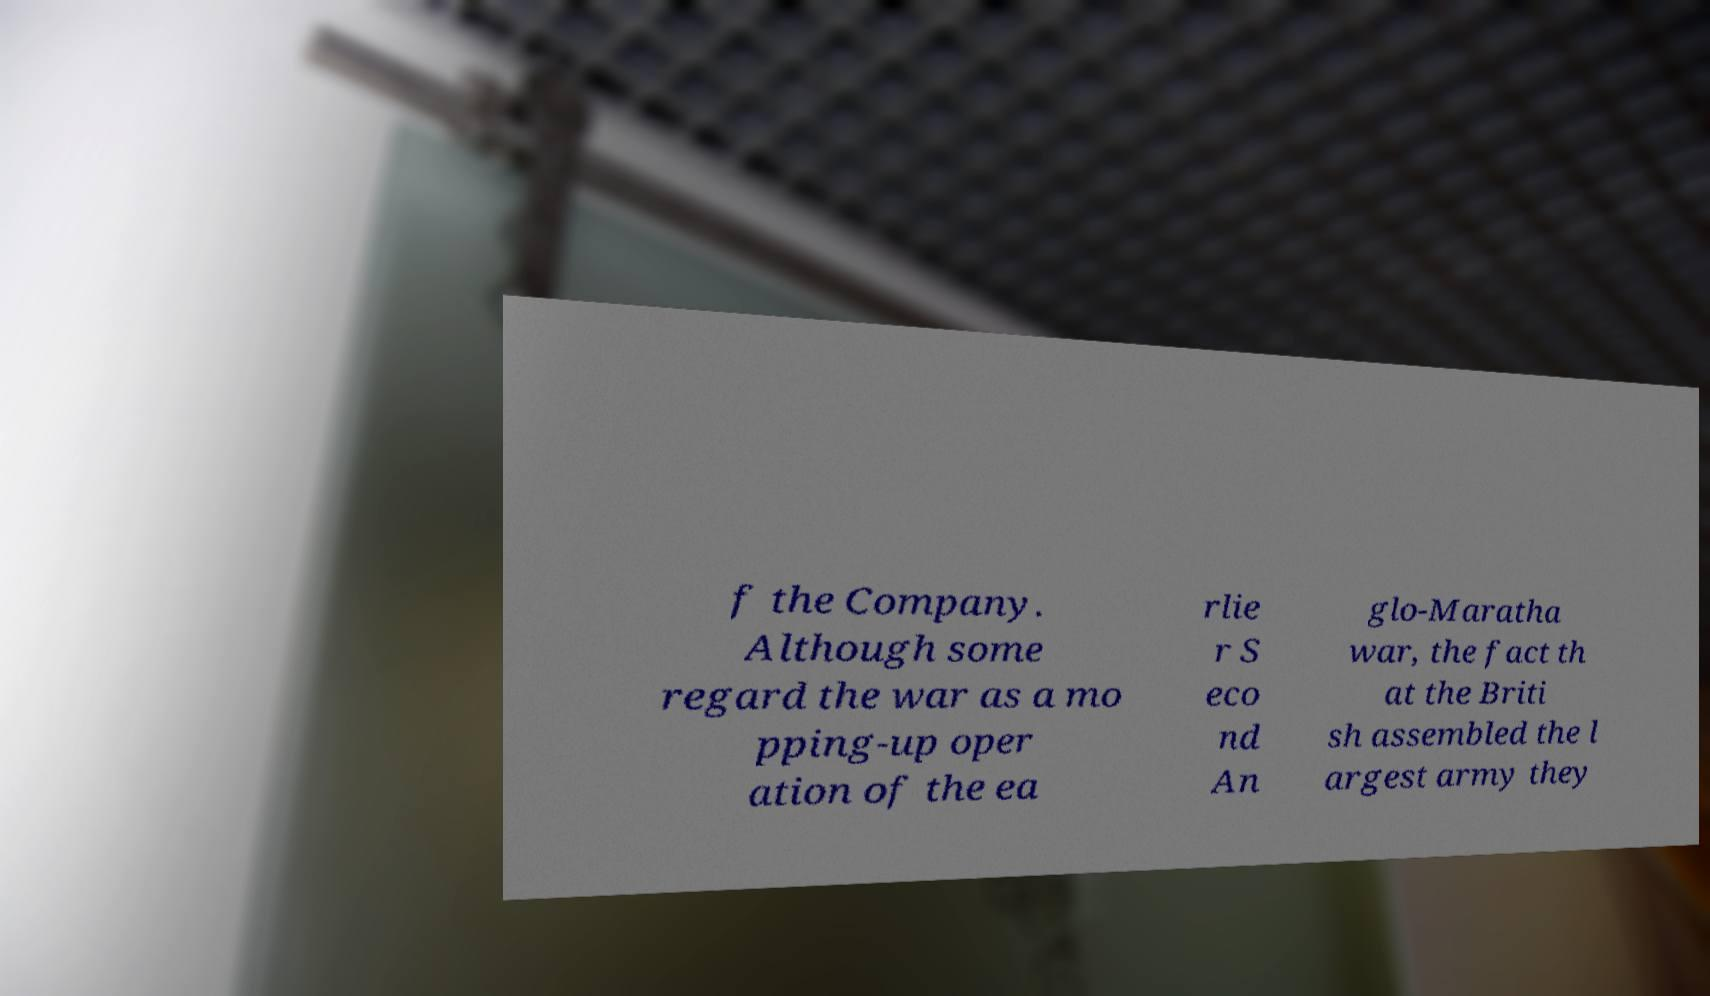What messages or text are displayed in this image? I need them in a readable, typed format. f the Company. Although some regard the war as a mo pping-up oper ation of the ea rlie r S eco nd An glo-Maratha war, the fact th at the Briti sh assembled the l argest army they 